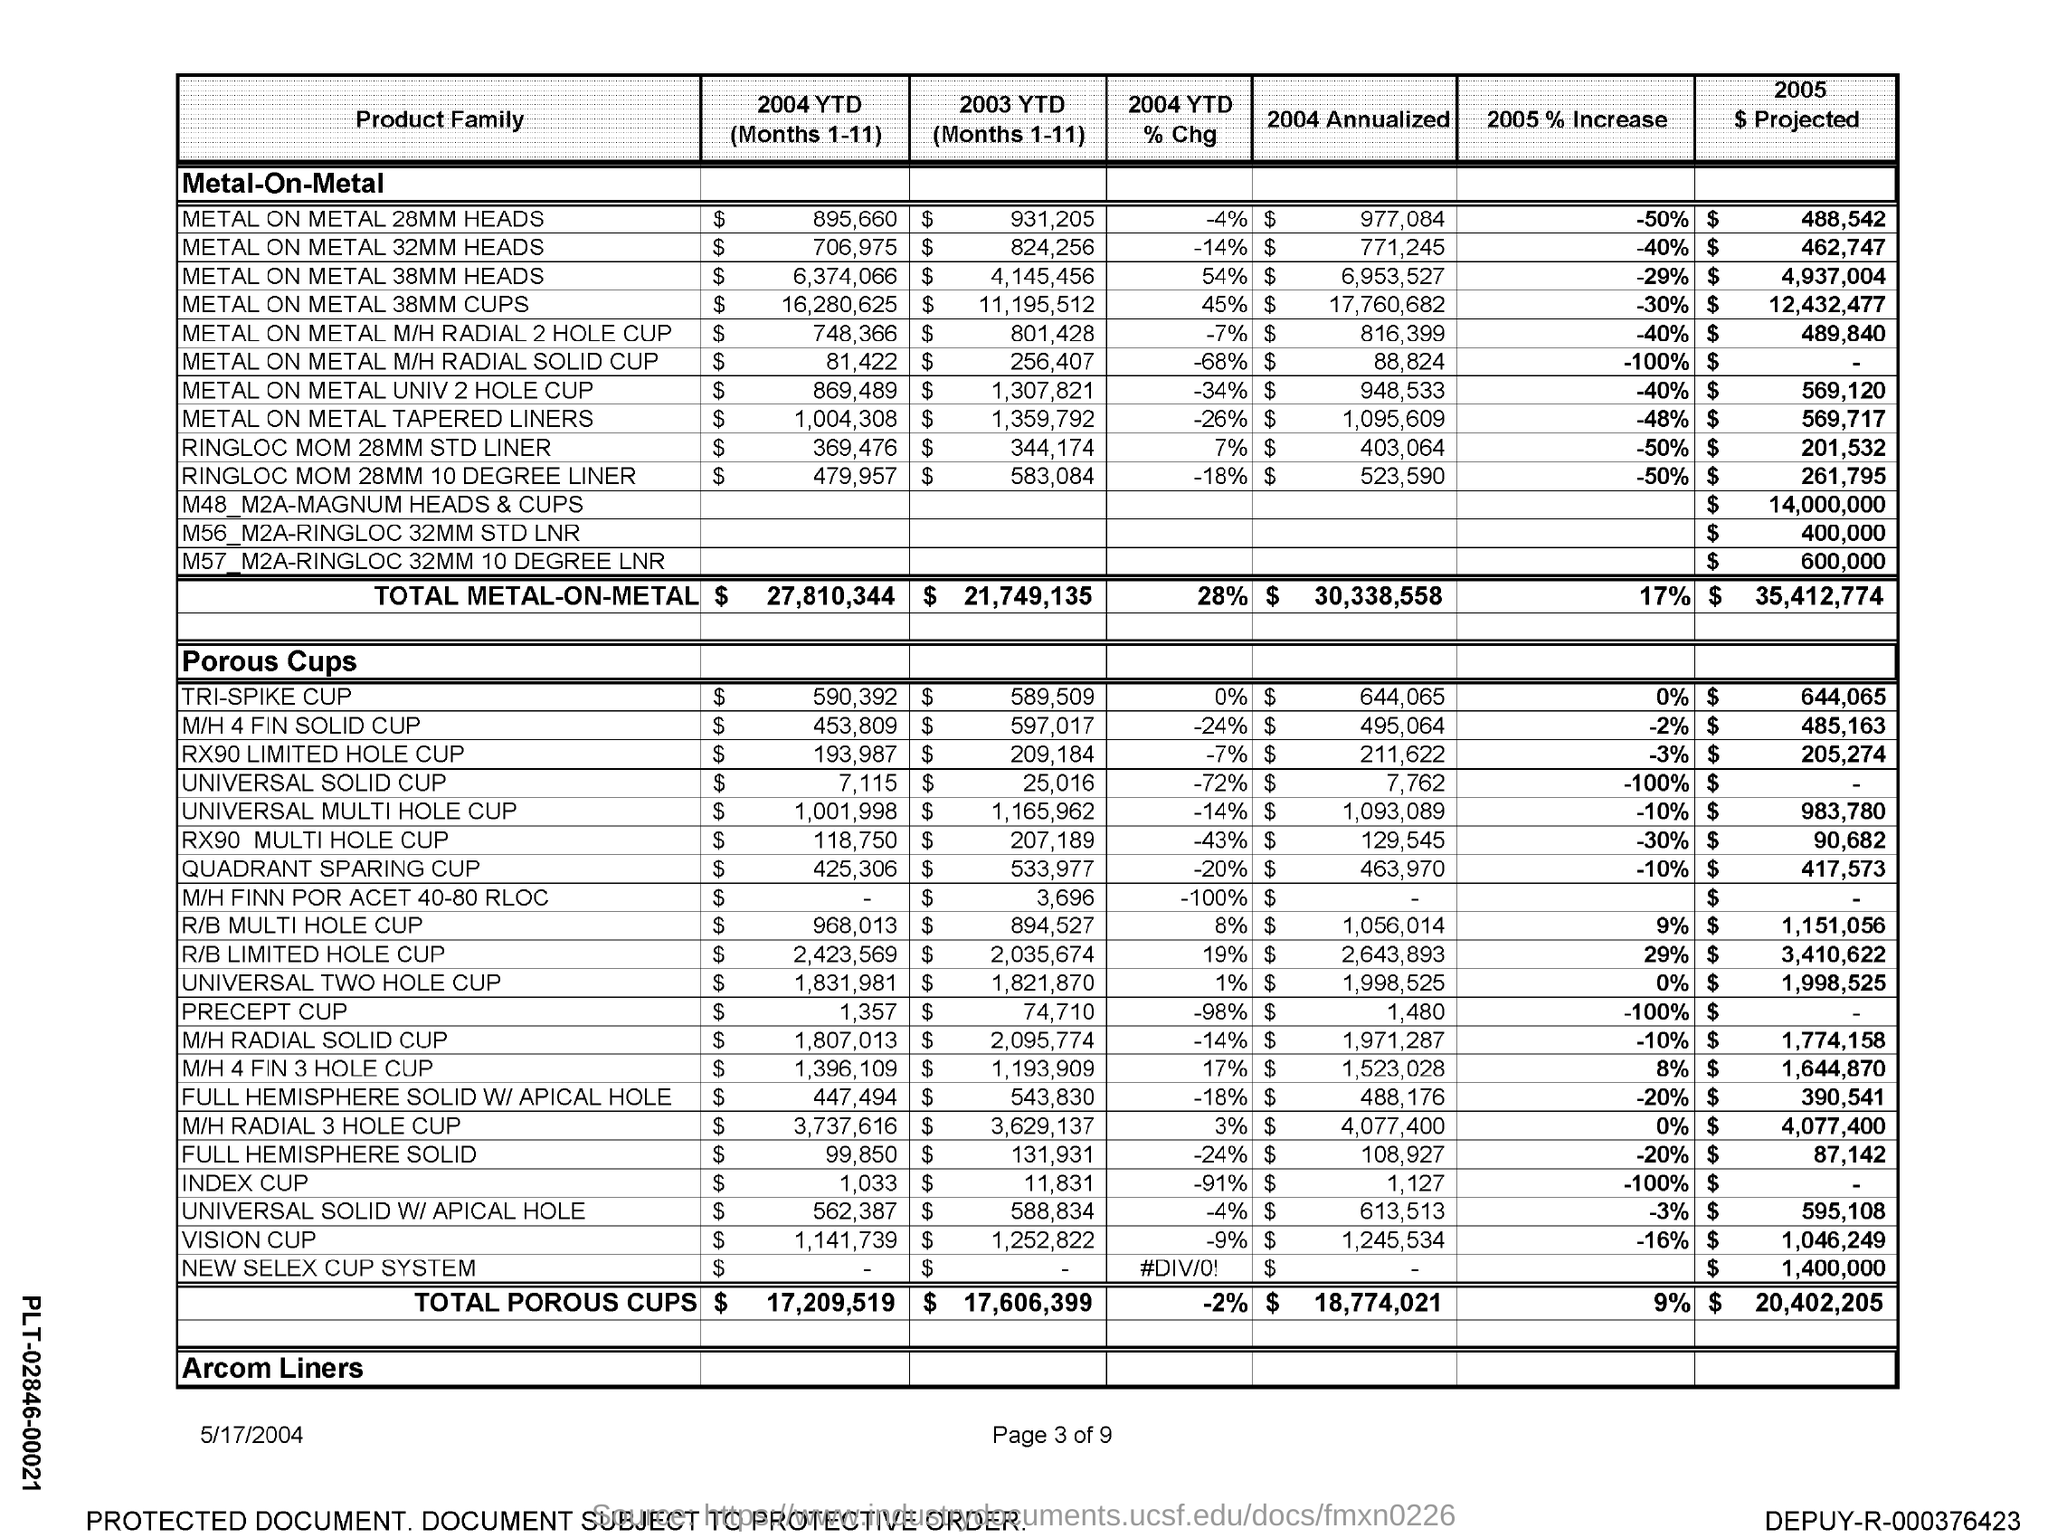Mention a couple of crucial points in this snapshot. According to data from 2005, the total increase in metal-on-metal implants was 2005%. Specifically, it was 17%. 